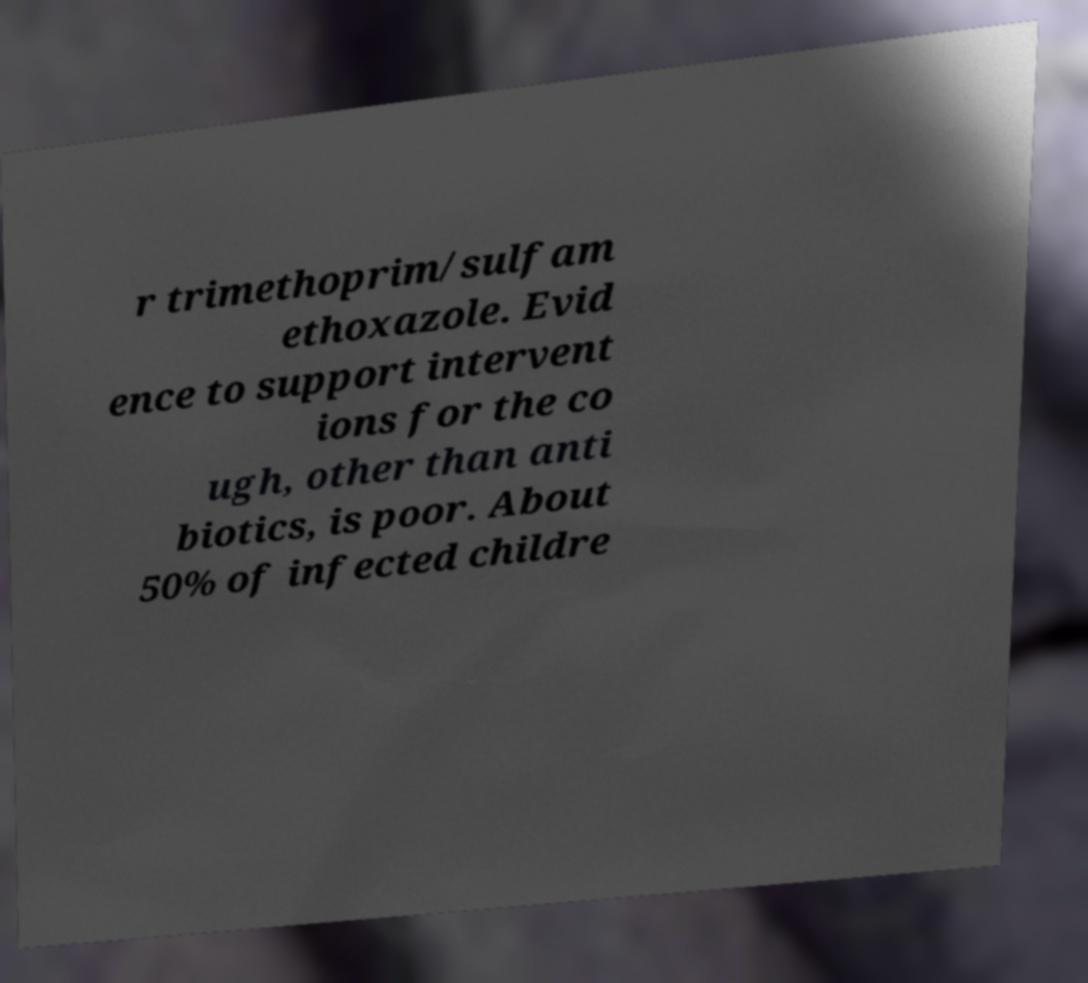For documentation purposes, I need the text within this image transcribed. Could you provide that? r trimethoprim/sulfam ethoxazole. Evid ence to support intervent ions for the co ugh, other than anti biotics, is poor. About 50% of infected childre 